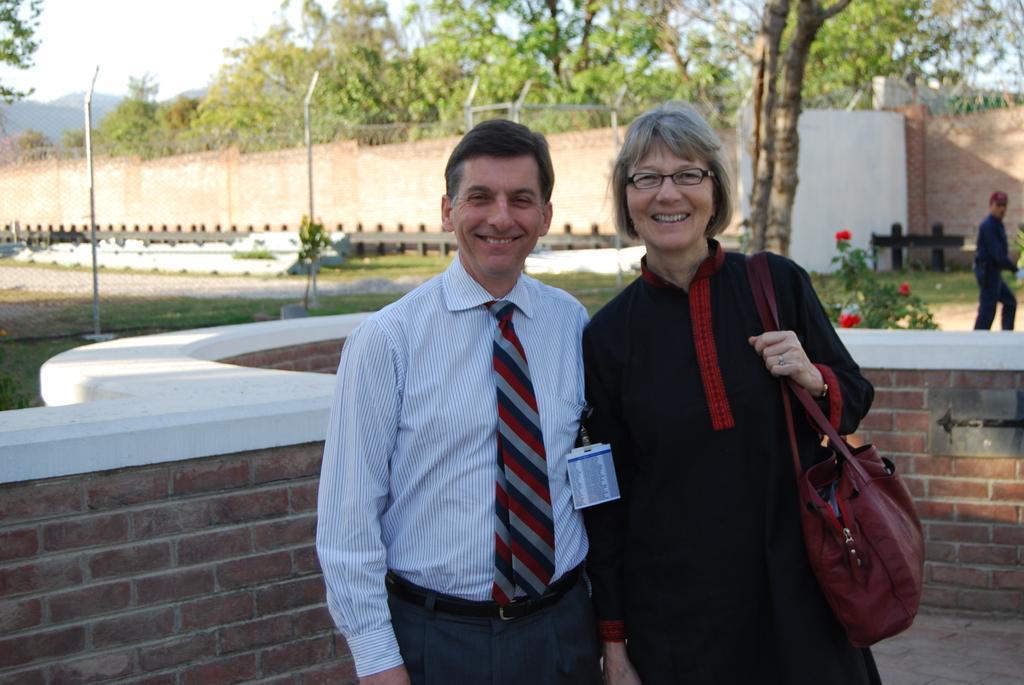In one or two sentences, can you explain what this image depicts? In this picture we can see group of people, in the middle of the image we can see a man and woman, they both are smiling and she wore a bag, in the background we can see few trees, plants, metal rods and flowers. 